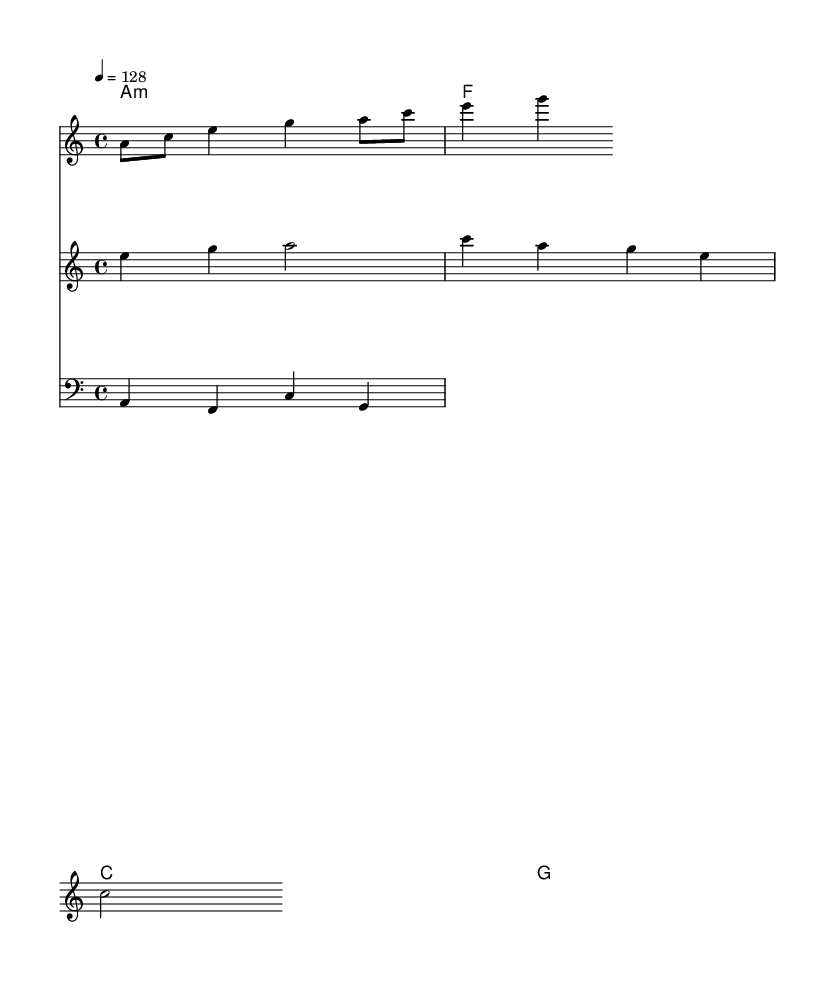What is the key signature of this music? The key signature shows one flat (B♭), indicating that the piece is in A minor.
Answer: A minor What is the time signature of this music? The time signature is indicated at the beginning of the score and shows 4 beats in every measure, represented as 4/4.
Answer: 4/4 What is the tempo marking of this piece? The tempo marking is notated in beats per minute and is indicated as 128, which suggests a moderately fast pace.
Answer: 128 How many lyrics are in the melodic line? There are five lines of lyrics that follow the vocal notes, each corresponding to a phrase of the melody.
Answer: 5 In which octave is the melody primarily located? By analyzing the melody notes, we notice that they are primarily in the treble clef, which indicates that the melody is primarily in a higher range. This is typical for uplifting tracks.
Answer: Treble Which musical elements contribute to the uplifting nature of this house track? The uplifting nature is primarily created by the angelic vocals, rich harmonies, and melodic motifs that ascend, combined with the steady dance tempo and spiritual lyrics. This combination fosters an atmosphere of positivity and enlightenment.
Answer: Vocals and harmony 